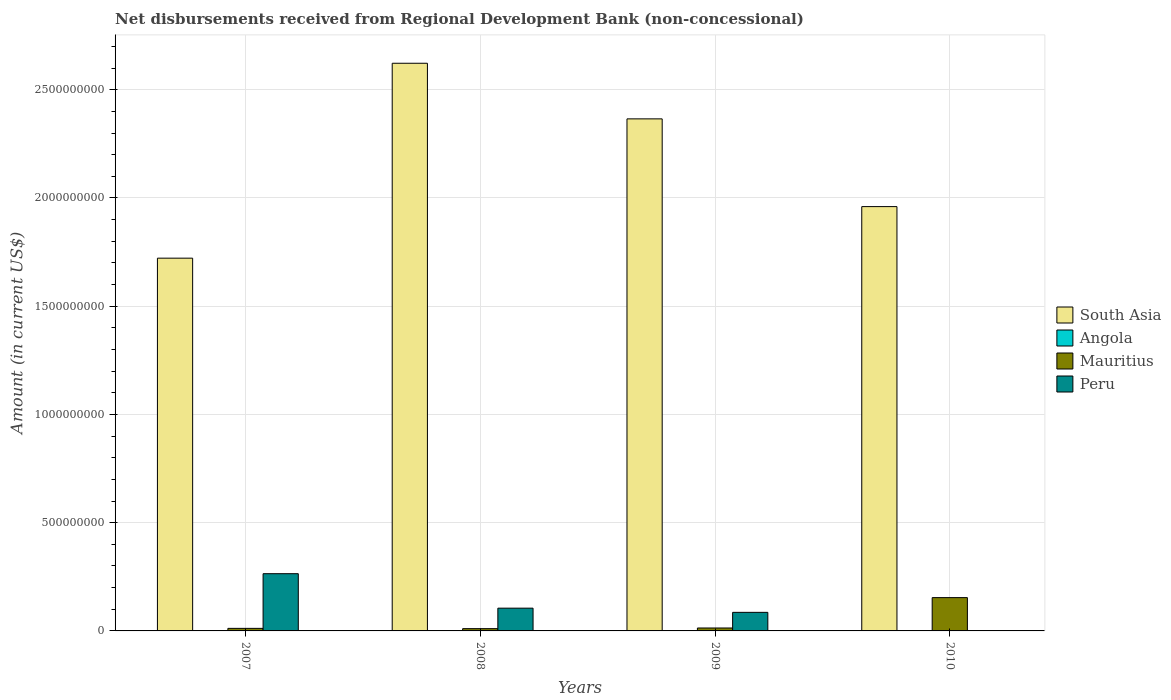How many different coloured bars are there?
Offer a very short reply. 3. How many groups of bars are there?
Your answer should be compact. 4. Are the number of bars on each tick of the X-axis equal?
Offer a very short reply. No. What is the amount of disbursements received from Regional Development Bank in Mauritius in 2010?
Give a very brief answer. 1.54e+08. Across all years, what is the maximum amount of disbursements received from Regional Development Bank in South Asia?
Ensure brevity in your answer.  2.62e+09. Across all years, what is the minimum amount of disbursements received from Regional Development Bank in Angola?
Give a very brief answer. 0. In which year was the amount of disbursements received from Regional Development Bank in Peru maximum?
Ensure brevity in your answer.  2007. What is the total amount of disbursements received from Regional Development Bank in Angola in the graph?
Give a very brief answer. 0. What is the difference between the amount of disbursements received from Regional Development Bank in Peru in 2007 and that in 2008?
Offer a terse response. 1.59e+08. What is the difference between the amount of disbursements received from Regional Development Bank in Peru in 2010 and the amount of disbursements received from Regional Development Bank in Angola in 2009?
Ensure brevity in your answer.  0. What is the average amount of disbursements received from Regional Development Bank in Mauritius per year?
Give a very brief answer. 4.74e+07. In the year 2008, what is the difference between the amount of disbursements received from Regional Development Bank in Peru and amount of disbursements received from Regional Development Bank in Mauritius?
Offer a terse response. 9.46e+07. In how many years, is the amount of disbursements received from Regional Development Bank in South Asia greater than 1300000000 US$?
Provide a succinct answer. 4. What is the ratio of the amount of disbursements received from Regional Development Bank in Mauritius in 2008 to that in 2010?
Give a very brief answer. 0.07. What is the difference between the highest and the second highest amount of disbursements received from Regional Development Bank in Peru?
Provide a succinct answer. 1.59e+08. What is the difference between the highest and the lowest amount of disbursements received from Regional Development Bank in Peru?
Ensure brevity in your answer.  2.64e+08. Is it the case that in every year, the sum of the amount of disbursements received from Regional Development Bank in Angola and amount of disbursements received from Regional Development Bank in Peru is greater than the sum of amount of disbursements received from Regional Development Bank in South Asia and amount of disbursements received from Regional Development Bank in Mauritius?
Provide a short and direct response. No. Is it the case that in every year, the sum of the amount of disbursements received from Regional Development Bank in Peru and amount of disbursements received from Regional Development Bank in Mauritius is greater than the amount of disbursements received from Regional Development Bank in South Asia?
Offer a terse response. No. Are the values on the major ticks of Y-axis written in scientific E-notation?
Your response must be concise. No. Does the graph contain any zero values?
Keep it short and to the point. Yes. Does the graph contain grids?
Keep it short and to the point. Yes. What is the title of the graph?
Offer a terse response. Net disbursements received from Regional Development Bank (non-concessional). Does "Fiji" appear as one of the legend labels in the graph?
Give a very brief answer. No. What is the label or title of the X-axis?
Offer a terse response. Years. What is the label or title of the Y-axis?
Your response must be concise. Amount (in current US$). What is the Amount (in current US$) of South Asia in 2007?
Your answer should be compact. 1.72e+09. What is the Amount (in current US$) in Angola in 2007?
Provide a short and direct response. 0. What is the Amount (in current US$) in Mauritius in 2007?
Your response must be concise. 1.18e+07. What is the Amount (in current US$) of Peru in 2007?
Provide a succinct answer. 2.64e+08. What is the Amount (in current US$) in South Asia in 2008?
Provide a short and direct response. 2.62e+09. What is the Amount (in current US$) of Angola in 2008?
Make the answer very short. 0. What is the Amount (in current US$) of Mauritius in 2008?
Your answer should be very brief. 1.05e+07. What is the Amount (in current US$) of Peru in 2008?
Your answer should be very brief. 1.05e+08. What is the Amount (in current US$) in South Asia in 2009?
Give a very brief answer. 2.37e+09. What is the Amount (in current US$) in Angola in 2009?
Offer a terse response. 0. What is the Amount (in current US$) of Mauritius in 2009?
Your answer should be very brief. 1.36e+07. What is the Amount (in current US$) of Peru in 2009?
Offer a terse response. 8.58e+07. What is the Amount (in current US$) in South Asia in 2010?
Your response must be concise. 1.96e+09. What is the Amount (in current US$) in Mauritius in 2010?
Give a very brief answer. 1.54e+08. Across all years, what is the maximum Amount (in current US$) of South Asia?
Keep it short and to the point. 2.62e+09. Across all years, what is the maximum Amount (in current US$) of Mauritius?
Make the answer very short. 1.54e+08. Across all years, what is the maximum Amount (in current US$) of Peru?
Make the answer very short. 2.64e+08. Across all years, what is the minimum Amount (in current US$) in South Asia?
Your answer should be very brief. 1.72e+09. Across all years, what is the minimum Amount (in current US$) in Mauritius?
Offer a very short reply. 1.05e+07. Across all years, what is the minimum Amount (in current US$) in Peru?
Provide a succinct answer. 0. What is the total Amount (in current US$) of South Asia in the graph?
Your response must be concise. 8.67e+09. What is the total Amount (in current US$) in Mauritius in the graph?
Your answer should be compact. 1.90e+08. What is the total Amount (in current US$) in Peru in the graph?
Keep it short and to the point. 4.55e+08. What is the difference between the Amount (in current US$) of South Asia in 2007 and that in 2008?
Your answer should be very brief. -9.00e+08. What is the difference between the Amount (in current US$) in Mauritius in 2007 and that in 2008?
Your answer should be compact. 1.32e+06. What is the difference between the Amount (in current US$) of Peru in 2007 and that in 2008?
Make the answer very short. 1.59e+08. What is the difference between the Amount (in current US$) of South Asia in 2007 and that in 2009?
Offer a very short reply. -6.43e+08. What is the difference between the Amount (in current US$) of Mauritius in 2007 and that in 2009?
Provide a short and direct response. -1.73e+06. What is the difference between the Amount (in current US$) in Peru in 2007 and that in 2009?
Ensure brevity in your answer.  1.79e+08. What is the difference between the Amount (in current US$) in South Asia in 2007 and that in 2010?
Your answer should be very brief. -2.38e+08. What is the difference between the Amount (in current US$) in Mauritius in 2007 and that in 2010?
Keep it short and to the point. -1.42e+08. What is the difference between the Amount (in current US$) of South Asia in 2008 and that in 2009?
Keep it short and to the point. 2.57e+08. What is the difference between the Amount (in current US$) in Mauritius in 2008 and that in 2009?
Offer a terse response. -3.05e+06. What is the difference between the Amount (in current US$) in Peru in 2008 and that in 2009?
Keep it short and to the point. 1.93e+07. What is the difference between the Amount (in current US$) of South Asia in 2008 and that in 2010?
Provide a short and direct response. 6.62e+08. What is the difference between the Amount (in current US$) in Mauritius in 2008 and that in 2010?
Your answer should be very brief. -1.43e+08. What is the difference between the Amount (in current US$) in South Asia in 2009 and that in 2010?
Your answer should be very brief. 4.05e+08. What is the difference between the Amount (in current US$) of Mauritius in 2009 and that in 2010?
Make the answer very short. -1.40e+08. What is the difference between the Amount (in current US$) of South Asia in 2007 and the Amount (in current US$) of Mauritius in 2008?
Offer a very short reply. 1.71e+09. What is the difference between the Amount (in current US$) in South Asia in 2007 and the Amount (in current US$) in Peru in 2008?
Your answer should be very brief. 1.62e+09. What is the difference between the Amount (in current US$) of Mauritius in 2007 and the Amount (in current US$) of Peru in 2008?
Keep it short and to the point. -9.33e+07. What is the difference between the Amount (in current US$) in South Asia in 2007 and the Amount (in current US$) in Mauritius in 2009?
Provide a succinct answer. 1.71e+09. What is the difference between the Amount (in current US$) in South Asia in 2007 and the Amount (in current US$) in Peru in 2009?
Keep it short and to the point. 1.64e+09. What is the difference between the Amount (in current US$) of Mauritius in 2007 and the Amount (in current US$) of Peru in 2009?
Offer a very short reply. -7.40e+07. What is the difference between the Amount (in current US$) in South Asia in 2007 and the Amount (in current US$) in Mauritius in 2010?
Your answer should be very brief. 1.57e+09. What is the difference between the Amount (in current US$) in South Asia in 2008 and the Amount (in current US$) in Mauritius in 2009?
Your response must be concise. 2.61e+09. What is the difference between the Amount (in current US$) of South Asia in 2008 and the Amount (in current US$) of Peru in 2009?
Your response must be concise. 2.54e+09. What is the difference between the Amount (in current US$) in Mauritius in 2008 and the Amount (in current US$) in Peru in 2009?
Make the answer very short. -7.53e+07. What is the difference between the Amount (in current US$) of South Asia in 2008 and the Amount (in current US$) of Mauritius in 2010?
Your answer should be very brief. 2.47e+09. What is the difference between the Amount (in current US$) of South Asia in 2009 and the Amount (in current US$) of Mauritius in 2010?
Ensure brevity in your answer.  2.21e+09. What is the average Amount (in current US$) of South Asia per year?
Provide a short and direct response. 2.17e+09. What is the average Amount (in current US$) in Angola per year?
Your response must be concise. 0. What is the average Amount (in current US$) of Mauritius per year?
Ensure brevity in your answer.  4.74e+07. What is the average Amount (in current US$) in Peru per year?
Provide a succinct answer. 1.14e+08. In the year 2007, what is the difference between the Amount (in current US$) of South Asia and Amount (in current US$) of Mauritius?
Provide a short and direct response. 1.71e+09. In the year 2007, what is the difference between the Amount (in current US$) of South Asia and Amount (in current US$) of Peru?
Offer a very short reply. 1.46e+09. In the year 2007, what is the difference between the Amount (in current US$) in Mauritius and Amount (in current US$) in Peru?
Offer a terse response. -2.53e+08. In the year 2008, what is the difference between the Amount (in current US$) in South Asia and Amount (in current US$) in Mauritius?
Make the answer very short. 2.61e+09. In the year 2008, what is the difference between the Amount (in current US$) of South Asia and Amount (in current US$) of Peru?
Your answer should be compact. 2.52e+09. In the year 2008, what is the difference between the Amount (in current US$) of Mauritius and Amount (in current US$) of Peru?
Ensure brevity in your answer.  -9.46e+07. In the year 2009, what is the difference between the Amount (in current US$) in South Asia and Amount (in current US$) in Mauritius?
Your response must be concise. 2.35e+09. In the year 2009, what is the difference between the Amount (in current US$) of South Asia and Amount (in current US$) of Peru?
Provide a short and direct response. 2.28e+09. In the year 2009, what is the difference between the Amount (in current US$) of Mauritius and Amount (in current US$) of Peru?
Offer a very short reply. -7.22e+07. In the year 2010, what is the difference between the Amount (in current US$) in South Asia and Amount (in current US$) in Mauritius?
Keep it short and to the point. 1.81e+09. What is the ratio of the Amount (in current US$) of South Asia in 2007 to that in 2008?
Give a very brief answer. 0.66. What is the ratio of the Amount (in current US$) of Mauritius in 2007 to that in 2008?
Offer a terse response. 1.13. What is the ratio of the Amount (in current US$) of Peru in 2007 to that in 2008?
Your answer should be very brief. 2.51. What is the ratio of the Amount (in current US$) in South Asia in 2007 to that in 2009?
Offer a terse response. 0.73. What is the ratio of the Amount (in current US$) of Mauritius in 2007 to that in 2009?
Give a very brief answer. 0.87. What is the ratio of the Amount (in current US$) in Peru in 2007 to that in 2009?
Give a very brief answer. 3.08. What is the ratio of the Amount (in current US$) in South Asia in 2007 to that in 2010?
Provide a succinct answer. 0.88. What is the ratio of the Amount (in current US$) of Mauritius in 2007 to that in 2010?
Your answer should be very brief. 0.08. What is the ratio of the Amount (in current US$) of South Asia in 2008 to that in 2009?
Provide a short and direct response. 1.11. What is the ratio of the Amount (in current US$) in Mauritius in 2008 to that in 2009?
Provide a short and direct response. 0.78. What is the ratio of the Amount (in current US$) of Peru in 2008 to that in 2009?
Ensure brevity in your answer.  1.23. What is the ratio of the Amount (in current US$) of South Asia in 2008 to that in 2010?
Make the answer very short. 1.34. What is the ratio of the Amount (in current US$) in Mauritius in 2008 to that in 2010?
Your answer should be very brief. 0.07. What is the ratio of the Amount (in current US$) in South Asia in 2009 to that in 2010?
Your response must be concise. 1.21. What is the ratio of the Amount (in current US$) in Mauritius in 2009 to that in 2010?
Your answer should be very brief. 0.09. What is the difference between the highest and the second highest Amount (in current US$) of South Asia?
Keep it short and to the point. 2.57e+08. What is the difference between the highest and the second highest Amount (in current US$) of Mauritius?
Your answer should be compact. 1.40e+08. What is the difference between the highest and the second highest Amount (in current US$) in Peru?
Give a very brief answer. 1.59e+08. What is the difference between the highest and the lowest Amount (in current US$) in South Asia?
Your response must be concise. 9.00e+08. What is the difference between the highest and the lowest Amount (in current US$) in Mauritius?
Your response must be concise. 1.43e+08. What is the difference between the highest and the lowest Amount (in current US$) of Peru?
Offer a terse response. 2.64e+08. 